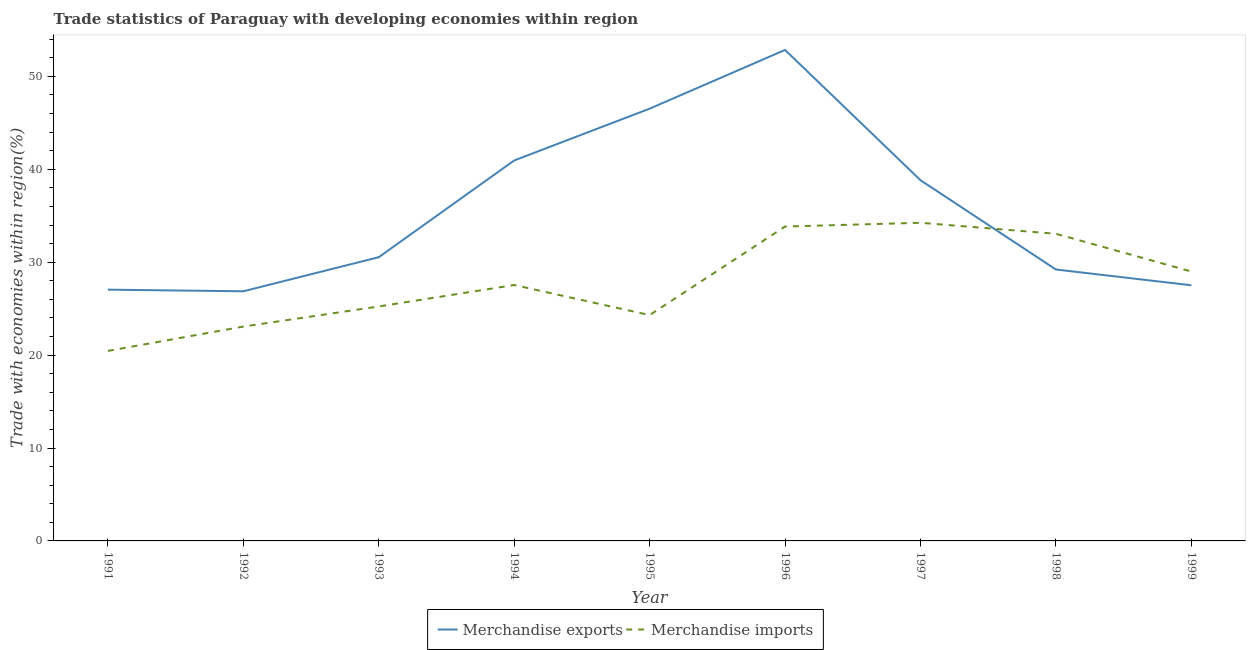What is the merchandise exports in 1993?
Offer a terse response. 30.54. Across all years, what is the maximum merchandise imports?
Your answer should be compact. 34.25. Across all years, what is the minimum merchandise imports?
Offer a terse response. 20.45. What is the total merchandise exports in the graph?
Make the answer very short. 320.35. What is the difference between the merchandise imports in 1992 and that in 1994?
Ensure brevity in your answer.  -4.47. What is the difference between the merchandise exports in 1993 and the merchandise imports in 1998?
Keep it short and to the point. -2.52. What is the average merchandise exports per year?
Provide a succinct answer. 35.59. In the year 1996, what is the difference between the merchandise exports and merchandise imports?
Your answer should be very brief. 19.01. In how many years, is the merchandise exports greater than 20 %?
Keep it short and to the point. 9. What is the ratio of the merchandise exports in 1995 to that in 1998?
Your answer should be compact. 1.59. Is the merchandise exports in 1993 less than that in 1998?
Your response must be concise. No. What is the difference between the highest and the second highest merchandise exports?
Your answer should be very brief. 6.32. What is the difference between the highest and the lowest merchandise exports?
Provide a succinct answer. 25.98. Is the sum of the merchandise exports in 1991 and 1996 greater than the maximum merchandise imports across all years?
Ensure brevity in your answer.  Yes. Is the merchandise imports strictly greater than the merchandise exports over the years?
Provide a short and direct response. No. Is the merchandise imports strictly less than the merchandise exports over the years?
Make the answer very short. No. Does the graph contain any zero values?
Ensure brevity in your answer.  No. Does the graph contain grids?
Make the answer very short. No. Where does the legend appear in the graph?
Keep it short and to the point. Bottom center. How many legend labels are there?
Your answer should be compact. 2. What is the title of the graph?
Your response must be concise. Trade statistics of Paraguay with developing economies within region. What is the label or title of the X-axis?
Offer a very short reply. Year. What is the label or title of the Y-axis?
Your answer should be compact. Trade with economies within region(%). What is the Trade with economies within region(%) of Merchandise exports in 1991?
Keep it short and to the point. 27.05. What is the Trade with economies within region(%) in Merchandise imports in 1991?
Offer a terse response. 20.45. What is the Trade with economies within region(%) of Merchandise exports in 1992?
Make the answer very short. 26.87. What is the Trade with economies within region(%) in Merchandise imports in 1992?
Give a very brief answer. 23.07. What is the Trade with economies within region(%) of Merchandise exports in 1993?
Your response must be concise. 30.54. What is the Trade with economies within region(%) in Merchandise imports in 1993?
Give a very brief answer. 25.24. What is the Trade with economies within region(%) in Merchandise exports in 1994?
Make the answer very short. 40.95. What is the Trade with economies within region(%) of Merchandise imports in 1994?
Keep it short and to the point. 27.55. What is the Trade with economies within region(%) in Merchandise exports in 1995?
Ensure brevity in your answer.  46.53. What is the Trade with economies within region(%) in Merchandise imports in 1995?
Offer a very short reply. 24.31. What is the Trade with economies within region(%) of Merchandise exports in 1996?
Make the answer very short. 52.85. What is the Trade with economies within region(%) in Merchandise imports in 1996?
Offer a very short reply. 33.84. What is the Trade with economies within region(%) in Merchandise exports in 1997?
Provide a short and direct response. 38.83. What is the Trade with economies within region(%) of Merchandise imports in 1997?
Provide a short and direct response. 34.25. What is the Trade with economies within region(%) of Merchandise exports in 1998?
Provide a short and direct response. 29.22. What is the Trade with economies within region(%) of Merchandise imports in 1998?
Give a very brief answer. 33.06. What is the Trade with economies within region(%) in Merchandise exports in 1999?
Provide a short and direct response. 27.52. What is the Trade with economies within region(%) of Merchandise imports in 1999?
Provide a short and direct response. 29. Across all years, what is the maximum Trade with economies within region(%) in Merchandise exports?
Offer a terse response. 52.85. Across all years, what is the maximum Trade with economies within region(%) of Merchandise imports?
Give a very brief answer. 34.25. Across all years, what is the minimum Trade with economies within region(%) in Merchandise exports?
Ensure brevity in your answer.  26.87. Across all years, what is the minimum Trade with economies within region(%) in Merchandise imports?
Provide a short and direct response. 20.45. What is the total Trade with economies within region(%) in Merchandise exports in the graph?
Make the answer very short. 320.35. What is the total Trade with economies within region(%) in Merchandise imports in the graph?
Give a very brief answer. 250.76. What is the difference between the Trade with economies within region(%) in Merchandise exports in 1991 and that in 1992?
Your answer should be very brief. 0.18. What is the difference between the Trade with economies within region(%) in Merchandise imports in 1991 and that in 1992?
Offer a terse response. -2.62. What is the difference between the Trade with economies within region(%) of Merchandise exports in 1991 and that in 1993?
Offer a very short reply. -3.49. What is the difference between the Trade with economies within region(%) in Merchandise imports in 1991 and that in 1993?
Give a very brief answer. -4.79. What is the difference between the Trade with economies within region(%) in Merchandise exports in 1991 and that in 1994?
Offer a very short reply. -13.91. What is the difference between the Trade with economies within region(%) in Merchandise imports in 1991 and that in 1994?
Your response must be concise. -7.1. What is the difference between the Trade with economies within region(%) of Merchandise exports in 1991 and that in 1995?
Your answer should be compact. -19.48. What is the difference between the Trade with economies within region(%) of Merchandise imports in 1991 and that in 1995?
Make the answer very short. -3.86. What is the difference between the Trade with economies within region(%) in Merchandise exports in 1991 and that in 1996?
Offer a very short reply. -25.8. What is the difference between the Trade with economies within region(%) in Merchandise imports in 1991 and that in 1996?
Keep it short and to the point. -13.39. What is the difference between the Trade with economies within region(%) of Merchandise exports in 1991 and that in 1997?
Keep it short and to the point. -11.78. What is the difference between the Trade with economies within region(%) of Merchandise imports in 1991 and that in 1997?
Provide a succinct answer. -13.8. What is the difference between the Trade with economies within region(%) in Merchandise exports in 1991 and that in 1998?
Offer a terse response. -2.17. What is the difference between the Trade with economies within region(%) of Merchandise imports in 1991 and that in 1998?
Provide a succinct answer. -12.61. What is the difference between the Trade with economies within region(%) in Merchandise exports in 1991 and that in 1999?
Provide a short and direct response. -0.47. What is the difference between the Trade with economies within region(%) in Merchandise imports in 1991 and that in 1999?
Ensure brevity in your answer.  -8.55. What is the difference between the Trade with economies within region(%) of Merchandise exports in 1992 and that in 1993?
Ensure brevity in your answer.  -3.67. What is the difference between the Trade with economies within region(%) in Merchandise imports in 1992 and that in 1993?
Offer a terse response. -2.16. What is the difference between the Trade with economies within region(%) of Merchandise exports in 1992 and that in 1994?
Provide a succinct answer. -14.08. What is the difference between the Trade with economies within region(%) of Merchandise imports in 1992 and that in 1994?
Give a very brief answer. -4.47. What is the difference between the Trade with economies within region(%) of Merchandise exports in 1992 and that in 1995?
Make the answer very short. -19.66. What is the difference between the Trade with economies within region(%) of Merchandise imports in 1992 and that in 1995?
Ensure brevity in your answer.  -1.24. What is the difference between the Trade with economies within region(%) of Merchandise exports in 1992 and that in 1996?
Your response must be concise. -25.98. What is the difference between the Trade with economies within region(%) in Merchandise imports in 1992 and that in 1996?
Offer a terse response. -10.77. What is the difference between the Trade with economies within region(%) in Merchandise exports in 1992 and that in 1997?
Provide a short and direct response. -11.96. What is the difference between the Trade with economies within region(%) of Merchandise imports in 1992 and that in 1997?
Offer a very short reply. -11.17. What is the difference between the Trade with economies within region(%) of Merchandise exports in 1992 and that in 1998?
Provide a succinct answer. -2.35. What is the difference between the Trade with economies within region(%) in Merchandise imports in 1992 and that in 1998?
Your answer should be compact. -9.99. What is the difference between the Trade with economies within region(%) in Merchandise exports in 1992 and that in 1999?
Offer a very short reply. -0.65. What is the difference between the Trade with economies within region(%) in Merchandise imports in 1992 and that in 1999?
Your response must be concise. -5.93. What is the difference between the Trade with economies within region(%) in Merchandise exports in 1993 and that in 1994?
Provide a succinct answer. -10.41. What is the difference between the Trade with economies within region(%) of Merchandise imports in 1993 and that in 1994?
Ensure brevity in your answer.  -2.31. What is the difference between the Trade with economies within region(%) of Merchandise exports in 1993 and that in 1995?
Your response must be concise. -15.99. What is the difference between the Trade with economies within region(%) in Merchandise imports in 1993 and that in 1995?
Offer a very short reply. 0.93. What is the difference between the Trade with economies within region(%) in Merchandise exports in 1993 and that in 1996?
Provide a short and direct response. -22.31. What is the difference between the Trade with economies within region(%) in Merchandise imports in 1993 and that in 1996?
Your answer should be very brief. -8.6. What is the difference between the Trade with economies within region(%) of Merchandise exports in 1993 and that in 1997?
Offer a very short reply. -8.29. What is the difference between the Trade with economies within region(%) of Merchandise imports in 1993 and that in 1997?
Your answer should be very brief. -9.01. What is the difference between the Trade with economies within region(%) in Merchandise exports in 1993 and that in 1998?
Provide a short and direct response. 1.32. What is the difference between the Trade with economies within region(%) in Merchandise imports in 1993 and that in 1998?
Your answer should be compact. -7.83. What is the difference between the Trade with economies within region(%) in Merchandise exports in 1993 and that in 1999?
Your answer should be very brief. 3.02. What is the difference between the Trade with economies within region(%) of Merchandise imports in 1993 and that in 1999?
Make the answer very short. -3.77. What is the difference between the Trade with economies within region(%) of Merchandise exports in 1994 and that in 1995?
Your answer should be very brief. -5.57. What is the difference between the Trade with economies within region(%) of Merchandise imports in 1994 and that in 1995?
Give a very brief answer. 3.24. What is the difference between the Trade with economies within region(%) in Merchandise exports in 1994 and that in 1996?
Ensure brevity in your answer.  -11.9. What is the difference between the Trade with economies within region(%) of Merchandise imports in 1994 and that in 1996?
Ensure brevity in your answer.  -6.29. What is the difference between the Trade with economies within region(%) of Merchandise exports in 1994 and that in 1997?
Offer a very short reply. 2.12. What is the difference between the Trade with economies within region(%) in Merchandise imports in 1994 and that in 1997?
Make the answer very short. -6.7. What is the difference between the Trade with economies within region(%) in Merchandise exports in 1994 and that in 1998?
Your response must be concise. 11.74. What is the difference between the Trade with economies within region(%) of Merchandise imports in 1994 and that in 1998?
Offer a terse response. -5.51. What is the difference between the Trade with economies within region(%) in Merchandise exports in 1994 and that in 1999?
Provide a short and direct response. 13.43. What is the difference between the Trade with economies within region(%) in Merchandise imports in 1994 and that in 1999?
Offer a terse response. -1.45. What is the difference between the Trade with economies within region(%) in Merchandise exports in 1995 and that in 1996?
Your answer should be compact. -6.32. What is the difference between the Trade with economies within region(%) of Merchandise imports in 1995 and that in 1996?
Make the answer very short. -9.53. What is the difference between the Trade with economies within region(%) in Merchandise exports in 1995 and that in 1997?
Offer a terse response. 7.7. What is the difference between the Trade with economies within region(%) of Merchandise imports in 1995 and that in 1997?
Offer a very short reply. -9.94. What is the difference between the Trade with economies within region(%) of Merchandise exports in 1995 and that in 1998?
Offer a very short reply. 17.31. What is the difference between the Trade with economies within region(%) of Merchandise imports in 1995 and that in 1998?
Your answer should be very brief. -8.75. What is the difference between the Trade with economies within region(%) of Merchandise exports in 1995 and that in 1999?
Your answer should be very brief. 19.01. What is the difference between the Trade with economies within region(%) in Merchandise imports in 1995 and that in 1999?
Give a very brief answer. -4.69. What is the difference between the Trade with economies within region(%) of Merchandise exports in 1996 and that in 1997?
Offer a very short reply. 14.02. What is the difference between the Trade with economies within region(%) of Merchandise imports in 1996 and that in 1997?
Ensure brevity in your answer.  -0.41. What is the difference between the Trade with economies within region(%) of Merchandise exports in 1996 and that in 1998?
Provide a succinct answer. 23.63. What is the difference between the Trade with economies within region(%) in Merchandise imports in 1996 and that in 1998?
Offer a very short reply. 0.78. What is the difference between the Trade with economies within region(%) of Merchandise exports in 1996 and that in 1999?
Offer a terse response. 25.33. What is the difference between the Trade with economies within region(%) in Merchandise imports in 1996 and that in 1999?
Give a very brief answer. 4.84. What is the difference between the Trade with economies within region(%) in Merchandise exports in 1997 and that in 1998?
Make the answer very short. 9.61. What is the difference between the Trade with economies within region(%) in Merchandise imports in 1997 and that in 1998?
Your response must be concise. 1.18. What is the difference between the Trade with economies within region(%) in Merchandise exports in 1997 and that in 1999?
Your response must be concise. 11.31. What is the difference between the Trade with economies within region(%) in Merchandise imports in 1997 and that in 1999?
Provide a short and direct response. 5.24. What is the difference between the Trade with economies within region(%) in Merchandise exports in 1998 and that in 1999?
Provide a short and direct response. 1.7. What is the difference between the Trade with economies within region(%) of Merchandise imports in 1998 and that in 1999?
Make the answer very short. 4.06. What is the difference between the Trade with economies within region(%) in Merchandise exports in 1991 and the Trade with economies within region(%) in Merchandise imports in 1992?
Provide a succinct answer. 3.97. What is the difference between the Trade with economies within region(%) in Merchandise exports in 1991 and the Trade with economies within region(%) in Merchandise imports in 1993?
Provide a succinct answer. 1.81. What is the difference between the Trade with economies within region(%) of Merchandise exports in 1991 and the Trade with economies within region(%) of Merchandise imports in 1994?
Your answer should be very brief. -0.5. What is the difference between the Trade with economies within region(%) in Merchandise exports in 1991 and the Trade with economies within region(%) in Merchandise imports in 1995?
Offer a terse response. 2.74. What is the difference between the Trade with economies within region(%) in Merchandise exports in 1991 and the Trade with economies within region(%) in Merchandise imports in 1996?
Provide a succinct answer. -6.79. What is the difference between the Trade with economies within region(%) of Merchandise exports in 1991 and the Trade with economies within region(%) of Merchandise imports in 1997?
Provide a short and direct response. -7.2. What is the difference between the Trade with economies within region(%) of Merchandise exports in 1991 and the Trade with economies within region(%) of Merchandise imports in 1998?
Ensure brevity in your answer.  -6.02. What is the difference between the Trade with economies within region(%) in Merchandise exports in 1991 and the Trade with economies within region(%) in Merchandise imports in 1999?
Keep it short and to the point. -1.95. What is the difference between the Trade with economies within region(%) in Merchandise exports in 1992 and the Trade with economies within region(%) in Merchandise imports in 1993?
Provide a succinct answer. 1.64. What is the difference between the Trade with economies within region(%) of Merchandise exports in 1992 and the Trade with economies within region(%) of Merchandise imports in 1994?
Provide a short and direct response. -0.68. What is the difference between the Trade with economies within region(%) of Merchandise exports in 1992 and the Trade with economies within region(%) of Merchandise imports in 1995?
Make the answer very short. 2.56. What is the difference between the Trade with economies within region(%) in Merchandise exports in 1992 and the Trade with economies within region(%) in Merchandise imports in 1996?
Provide a succinct answer. -6.97. What is the difference between the Trade with economies within region(%) in Merchandise exports in 1992 and the Trade with economies within region(%) in Merchandise imports in 1997?
Give a very brief answer. -7.37. What is the difference between the Trade with economies within region(%) of Merchandise exports in 1992 and the Trade with economies within region(%) of Merchandise imports in 1998?
Offer a very short reply. -6.19. What is the difference between the Trade with economies within region(%) in Merchandise exports in 1992 and the Trade with economies within region(%) in Merchandise imports in 1999?
Your response must be concise. -2.13. What is the difference between the Trade with economies within region(%) in Merchandise exports in 1993 and the Trade with economies within region(%) in Merchandise imports in 1994?
Provide a succinct answer. 2.99. What is the difference between the Trade with economies within region(%) of Merchandise exports in 1993 and the Trade with economies within region(%) of Merchandise imports in 1995?
Offer a very short reply. 6.23. What is the difference between the Trade with economies within region(%) of Merchandise exports in 1993 and the Trade with economies within region(%) of Merchandise imports in 1996?
Ensure brevity in your answer.  -3.3. What is the difference between the Trade with economies within region(%) in Merchandise exports in 1993 and the Trade with economies within region(%) in Merchandise imports in 1997?
Your response must be concise. -3.71. What is the difference between the Trade with economies within region(%) of Merchandise exports in 1993 and the Trade with economies within region(%) of Merchandise imports in 1998?
Keep it short and to the point. -2.52. What is the difference between the Trade with economies within region(%) of Merchandise exports in 1993 and the Trade with economies within region(%) of Merchandise imports in 1999?
Keep it short and to the point. 1.54. What is the difference between the Trade with economies within region(%) of Merchandise exports in 1994 and the Trade with economies within region(%) of Merchandise imports in 1995?
Give a very brief answer. 16.64. What is the difference between the Trade with economies within region(%) in Merchandise exports in 1994 and the Trade with economies within region(%) in Merchandise imports in 1996?
Provide a succinct answer. 7.11. What is the difference between the Trade with economies within region(%) in Merchandise exports in 1994 and the Trade with economies within region(%) in Merchandise imports in 1997?
Offer a very short reply. 6.71. What is the difference between the Trade with economies within region(%) in Merchandise exports in 1994 and the Trade with economies within region(%) in Merchandise imports in 1998?
Your answer should be very brief. 7.89. What is the difference between the Trade with economies within region(%) of Merchandise exports in 1994 and the Trade with economies within region(%) of Merchandise imports in 1999?
Make the answer very short. 11.95. What is the difference between the Trade with economies within region(%) of Merchandise exports in 1995 and the Trade with economies within region(%) of Merchandise imports in 1996?
Make the answer very short. 12.69. What is the difference between the Trade with economies within region(%) of Merchandise exports in 1995 and the Trade with economies within region(%) of Merchandise imports in 1997?
Give a very brief answer. 12.28. What is the difference between the Trade with economies within region(%) of Merchandise exports in 1995 and the Trade with economies within region(%) of Merchandise imports in 1998?
Provide a succinct answer. 13.47. What is the difference between the Trade with economies within region(%) in Merchandise exports in 1995 and the Trade with economies within region(%) in Merchandise imports in 1999?
Keep it short and to the point. 17.53. What is the difference between the Trade with economies within region(%) in Merchandise exports in 1996 and the Trade with economies within region(%) in Merchandise imports in 1997?
Ensure brevity in your answer.  18.61. What is the difference between the Trade with economies within region(%) in Merchandise exports in 1996 and the Trade with economies within region(%) in Merchandise imports in 1998?
Offer a terse response. 19.79. What is the difference between the Trade with economies within region(%) in Merchandise exports in 1996 and the Trade with economies within region(%) in Merchandise imports in 1999?
Your answer should be very brief. 23.85. What is the difference between the Trade with economies within region(%) of Merchandise exports in 1997 and the Trade with economies within region(%) of Merchandise imports in 1998?
Offer a terse response. 5.77. What is the difference between the Trade with economies within region(%) of Merchandise exports in 1997 and the Trade with economies within region(%) of Merchandise imports in 1999?
Provide a short and direct response. 9.83. What is the difference between the Trade with economies within region(%) of Merchandise exports in 1998 and the Trade with economies within region(%) of Merchandise imports in 1999?
Offer a terse response. 0.22. What is the average Trade with economies within region(%) of Merchandise exports per year?
Ensure brevity in your answer.  35.59. What is the average Trade with economies within region(%) of Merchandise imports per year?
Provide a short and direct response. 27.86. In the year 1991, what is the difference between the Trade with economies within region(%) of Merchandise exports and Trade with economies within region(%) of Merchandise imports?
Give a very brief answer. 6.6. In the year 1992, what is the difference between the Trade with economies within region(%) in Merchandise exports and Trade with economies within region(%) in Merchandise imports?
Provide a succinct answer. 3.8. In the year 1993, what is the difference between the Trade with economies within region(%) of Merchandise exports and Trade with economies within region(%) of Merchandise imports?
Provide a short and direct response. 5.3. In the year 1994, what is the difference between the Trade with economies within region(%) of Merchandise exports and Trade with economies within region(%) of Merchandise imports?
Provide a short and direct response. 13.41. In the year 1995, what is the difference between the Trade with economies within region(%) in Merchandise exports and Trade with economies within region(%) in Merchandise imports?
Your response must be concise. 22.22. In the year 1996, what is the difference between the Trade with economies within region(%) in Merchandise exports and Trade with economies within region(%) in Merchandise imports?
Your answer should be very brief. 19.01. In the year 1997, what is the difference between the Trade with economies within region(%) of Merchandise exports and Trade with economies within region(%) of Merchandise imports?
Your answer should be compact. 4.58. In the year 1998, what is the difference between the Trade with economies within region(%) in Merchandise exports and Trade with economies within region(%) in Merchandise imports?
Ensure brevity in your answer.  -3.84. In the year 1999, what is the difference between the Trade with economies within region(%) of Merchandise exports and Trade with economies within region(%) of Merchandise imports?
Your answer should be very brief. -1.48. What is the ratio of the Trade with economies within region(%) in Merchandise imports in 1991 to that in 1992?
Your response must be concise. 0.89. What is the ratio of the Trade with economies within region(%) of Merchandise exports in 1991 to that in 1993?
Provide a succinct answer. 0.89. What is the ratio of the Trade with economies within region(%) of Merchandise imports in 1991 to that in 1993?
Ensure brevity in your answer.  0.81. What is the ratio of the Trade with economies within region(%) in Merchandise exports in 1991 to that in 1994?
Keep it short and to the point. 0.66. What is the ratio of the Trade with economies within region(%) of Merchandise imports in 1991 to that in 1994?
Provide a succinct answer. 0.74. What is the ratio of the Trade with economies within region(%) in Merchandise exports in 1991 to that in 1995?
Make the answer very short. 0.58. What is the ratio of the Trade with economies within region(%) in Merchandise imports in 1991 to that in 1995?
Your answer should be compact. 0.84. What is the ratio of the Trade with economies within region(%) of Merchandise exports in 1991 to that in 1996?
Offer a very short reply. 0.51. What is the ratio of the Trade with economies within region(%) in Merchandise imports in 1991 to that in 1996?
Make the answer very short. 0.6. What is the ratio of the Trade with economies within region(%) in Merchandise exports in 1991 to that in 1997?
Your answer should be very brief. 0.7. What is the ratio of the Trade with economies within region(%) of Merchandise imports in 1991 to that in 1997?
Provide a succinct answer. 0.6. What is the ratio of the Trade with economies within region(%) of Merchandise exports in 1991 to that in 1998?
Your response must be concise. 0.93. What is the ratio of the Trade with economies within region(%) in Merchandise imports in 1991 to that in 1998?
Keep it short and to the point. 0.62. What is the ratio of the Trade with economies within region(%) of Merchandise exports in 1991 to that in 1999?
Give a very brief answer. 0.98. What is the ratio of the Trade with economies within region(%) in Merchandise imports in 1991 to that in 1999?
Ensure brevity in your answer.  0.71. What is the ratio of the Trade with economies within region(%) of Merchandise exports in 1992 to that in 1993?
Keep it short and to the point. 0.88. What is the ratio of the Trade with economies within region(%) in Merchandise imports in 1992 to that in 1993?
Ensure brevity in your answer.  0.91. What is the ratio of the Trade with economies within region(%) in Merchandise exports in 1992 to that in 1994?
Ensure brevity in your answer.  0.66. What is the ratio of the Trade with economies within region(%) of Merchandise imports in 1992 to that in 1994?
Keep it short and to the point. 0.84. What is the ratio of the Trade with economies within region(%) in Merchandise exports in 1992 to that in 1995?
Offer a very short reply. 0.58. What is the ratio of the Trade with economies within region(%) of Merchandise imports in 1992 to that in 1995?
Make the answer very short. 0.95. What is the ratio of the Trade with economies within region(%) of Merchandise exports in 1992 to that in 1996?
Ensure brevity in your answer.  0.51. What is the ratio of the Trade with economies within region(%) of Merchandise imports in 1992 to that in 1996?
Your answer should be very brief. 0.68. What is the ratio of the Trade with economies within region(%) of Merchandise exports in 1992 to that in 1997?
Keep it short and to the point. 0.69. What is the ratio of the Trade with economies within region(%) in Merchandise imports in 1992 to that in 1997?
Your answer should be compact. 0.67. What is the ratio of the Trade with economies within region(%) in Merchandise exports in 1992 to that in 1998?
Give a very brief answer. 0.92. What is the ratio of the Trade with economies within region(%) in Merchandise imports in 1992 to that in 1998?
Your response must be concise. 0.7. What is the ratio of the Trade with economies within region(%) of Merchandise exports in 1992 to that in 1999?
Offer a terse response. 0.98. What is the ratio of the Trade with economies within region(%) in Merchandise imports in 1992 to that in 1999?
Ensure brevity in your answer.  0.8. What is the ratio of the Trade with economies within region(%) of Merchandise exports in 1993 to that in 1994?
Your response must be concise. 0.75. What is the ratio of the Trade with economies within region(%) of Merchandise imports in 1993 to that in 1994?
Offer a terse response. 0.92. What is the ratio of the Trade with economies within region(%) in Merchandise exports in 1993 to that in 1995?
Give a very brief answer. 0.66. What is the ratio of the Trade with economies within region(%) in Merchandise imports in 1993 to that in 1995?
Offer a very short reply. 1.04. What is the ratio of the Trade with economies within region(%) of Merchandise exports in 1993 to that in 1996?
Make the answer very short. 0.58. What is the ratio of the Trade with economies within region(%) in Merchandise imports in 1993 to that in 1996?
Ensure brevity in your answer.  0.75. What is the ratio of the Trade with economies within region(%) in Merchandise exports in 1993 to that in 1997?
Offer a terse response. 0.79. What is the ratio of the Trade with economies within region(%) of Merchandise imports in 1993 to that in 1997?
Your response must be concise. 0.74. What is the ratio of the Trade with economies within region(%) of Merchandise exports in 1993 to that in 1998?
Your answer should be compact. 1.05. What is the ratio of the Trade with economies within region(%) of Merchandise imports in 1993 to that in 1998?
Offer a very short reply. 0.76. What is the ratio of the Trade with economies within region(%) of Merchandise exports in 1993 to that in 1999?
Your answer should be compact. 1.11. What is the ratio of the Trade with economies within region(%) in Merchandise imports in 1993 to that in 1999?
Provide a succinct answer. 0.87. What is the ratio of the Trade with economies within region(%) of Merchandise exports in 1994 to that in 1995?
Your response must be concise. 0.88. What is the ratio of the Trade with economies within region(%) in Merchandise imports in 1994 to that in 1995?
Provide a succinct answer. 1.13. What is the ratio of the Trade with economies within region(%) of Merchandise exports in 1994 to that in 1996?
Your answer should be very brief. 0.77. What is the ratio of the Trade with economies within region(%) of Merchandise imports in 1994 to that in 1996?
Your answer should be compact. 0.81. What is the ratio of the Trade with economies within region(%) of Merchandise exports in 1994 to that in 1997?
Your answer should be very brief. 1.05. What is the ratio of the Trade with economies within region(%) of Merchandise imports in 1994 to that in 1997?
Provide a succinct answer. 0.8. What is the ratio of the Trade with economies within region(%) of Merchandise exports in 1994 to that in 1998?
Provide a succinct answer. 1.4. What is the ratio of the Trade with economies within region(%) of Merchandise imports in 1994 to that in 1998?
Your answer should be compact. 0.83. What is the ratio of the Trade with economies within region(%) in Merchandise exports in 1994 to that in 1999?
Provide a succinct answer. 1.49. What is the ratio of the Trade with economies within region(%) in Merchandise imports in 1994 to that in 1999?
Offer a terse response. 0.95. What is the ratio of the Trade with economies within region(%) of Merchandise exports in 1995 to that in 1996?
Your answer should be compact. 0.88. What is the ratio of the Trade with economies within region(%) in Merchandise imports in 1995 to that in 1996?
Your response must be concise. 0.72. What is the ratio of the Trade with economies within region(%) of Merchandise exports in 1995 to that in 1997?
Offer a terse response. 1.2. What is the ratio of the Trade with economies within region(%) of Merchandise imports in 1995 to that in 1997?
Your response must be concise. 0.71. What is the ratio of the Trade with economies within region(%) in Merchandise exports in 1995 to that in 1998?
Provide a succinct answer. 1.59. What is the ratio of the Trade with economies within region(%) of Merchandise imports in 1995 to that in 1998?
Make the answer very short. 0.74. What is the ratio of the Trade with economies within region(%) of Merchandise exports in 1995 to that in 1999?
Offer a very short reply. 1.69. What is the ratio of the Trade with economies within region(%) of Merchandise imports in 1995 to that in 1999?
Offer a terse response. 0.84. What is the ratio of the Trade with economies within region(%) in Merchandise exports in 1996 to that in 1997?
Offer a terse response. 1.36. What is the ratio of the Trade with economies within region(%) of Merchandise exports in 1996 to that in 1998?
Your answer should be compact. 1.81. What is the ratio of the Trade with economies within region(%) in Merchandise imports in 1996 to that in 1998?
Your response must be concise. 1.02. What is the ratio of the Trade with economies within region(%) of Merchandise exports in 1996 to that in 1999?
Provide a succinct answer. 1.92. What is the ratio of the Trade with economies within region(%) of Merchandise imports in 1996 to that in 1999?
Your answer should be compact. 1.17. What is the ratio of the Trade with economies within region(%) of Merchandise exports in 1997 to that in 1998?
Offer a terse response. 1.33. What is the ratio of the Trade with economies within region(%) of Merchandise imports in 1997 to that in 1998?
Your answer should be very brief. 1.04. What is the ratio of the Trade with economies within region(%) in Merchandise exports in 1997 to that in 1999?
Ensure brevity in your answer.  1.41. What is the ratio of the Trade with economies within region(%) in Merchandise imports in 1997 to that in 1999?
Your answer should be compact. 1.18. What is the ratio of the Trade with economies within region(%) of Merchandise exports in 1998 to that in 1999?
Your answer should be very brief. 1.06. What is the ratio of the Trade with economies within region(%) in Merchandise imports in 1998 to that in 1999?
Your response must be concise. 1.14. What is the difference between the highest and the second highest Trade with economies within region(%) of Merchandise exports?
Offer a very short reply. 6.32. What is the difference between the highest and the second highest Trade with economies within region(%) in Merchandise imports?
Offer a very short reply. 0.41. What is the difference between the highest and the lowest Trade with economies within region(%) of Merchandise exports?
Provide a short and direct response. 25.98. What is the difference between the highest and the lowest Trade with economies within region(%) of Merchandise imports?
Offer a terse response. 13.8. 